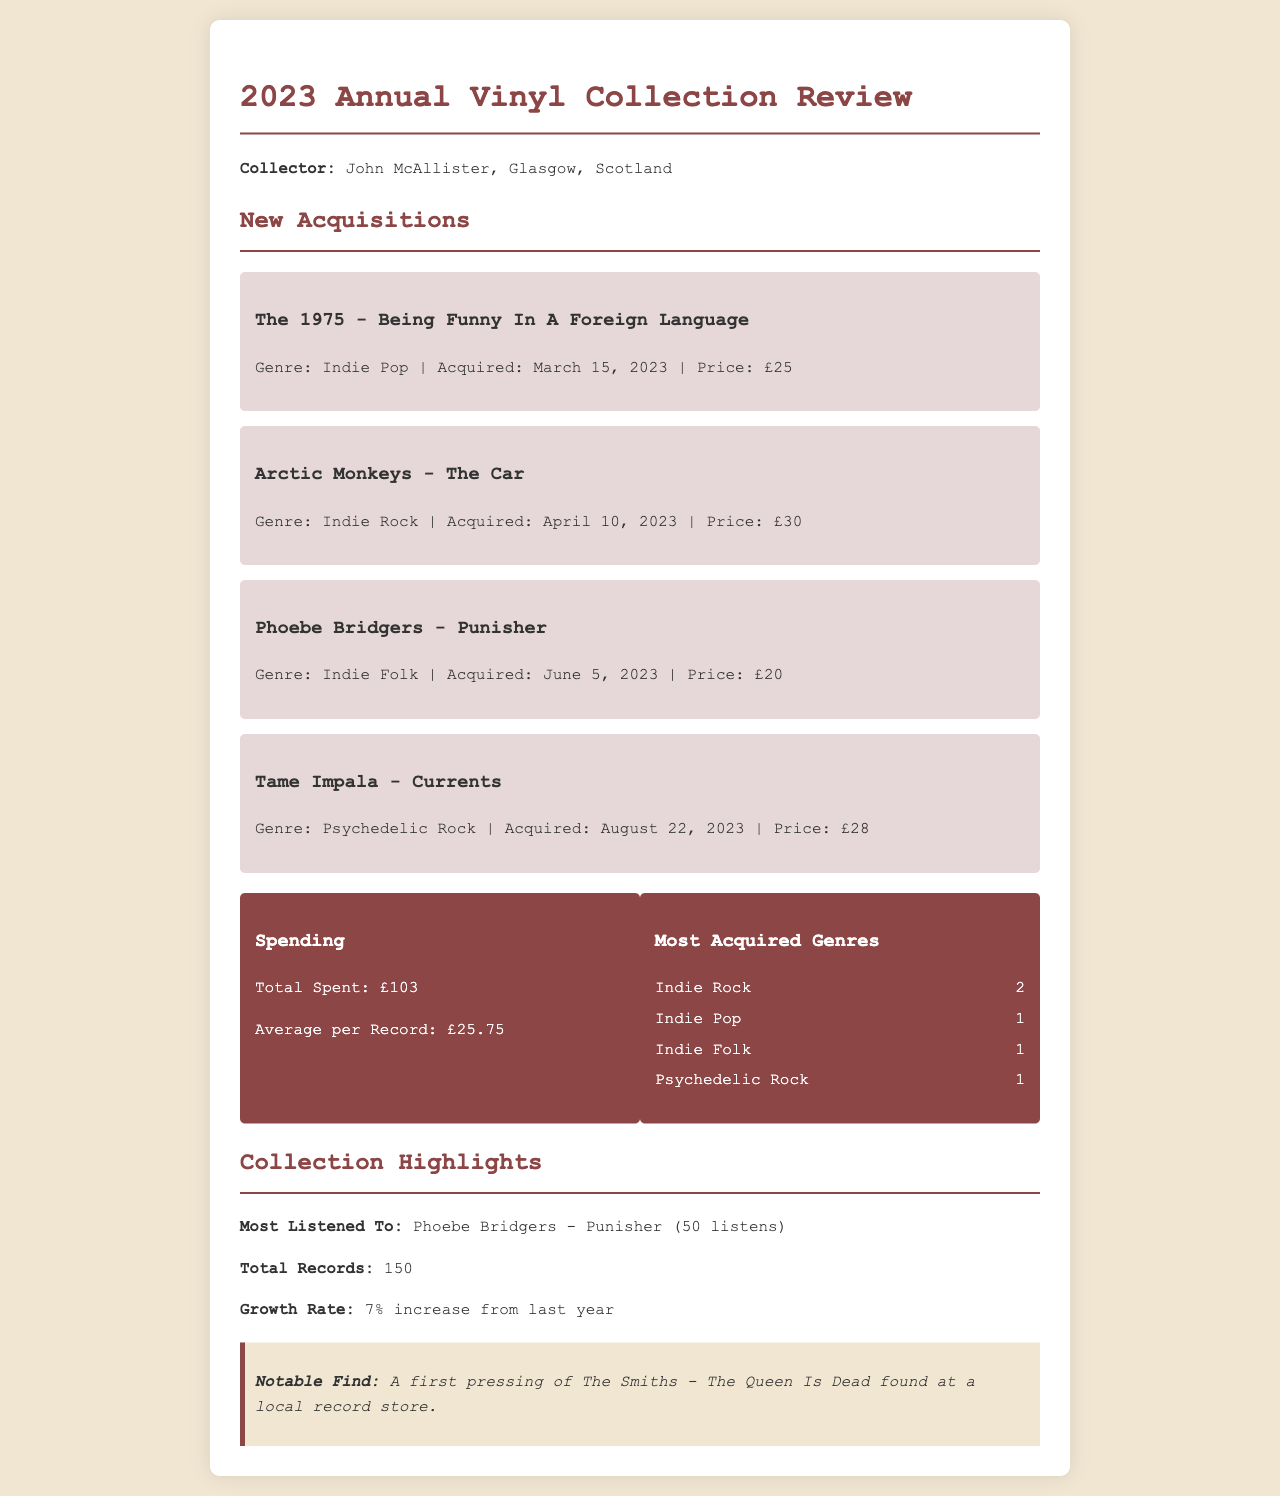What is the collector's name? The collector's name is stated at the beginning of the document.
Answer: John McAllister How many records were acquired in 2023? The total number of new acquisitions is summarized in the acquisitions section.
Answer: 4 What is the total spending on vinyl records? The total spending amount is provided in the statistics section of the document.
Answer: £103 Which record was listed as the most listened to? The most listened to record is indicated in the collection highlights section.
Answer: Phoebe Bridgers - Punisher What genre has the most acquisitions? The most acquired genres is discussed in the statistics section, detailing the counts.
Answer: Indie Rock What is the growth rate of the collection from last year? The growth rate is mentioned directly in the collection highlights section.
Answer: 7% When was Tame Impala - Currents acquired? The acquisition date for Tame Impala's record is mentioned in the acquisitions section.
Answer: August 22, 2023 How many listens did Phoebe Bridgers - Punisher receive? The number of listens is explicitly stated in the collection highlights section.
Answer: 50 listens What notable find was mentioned in the document? The notable find is noted in a dedicated section within the document.
Answer: A first pressing of The Smiths - The Queen Is Dead 